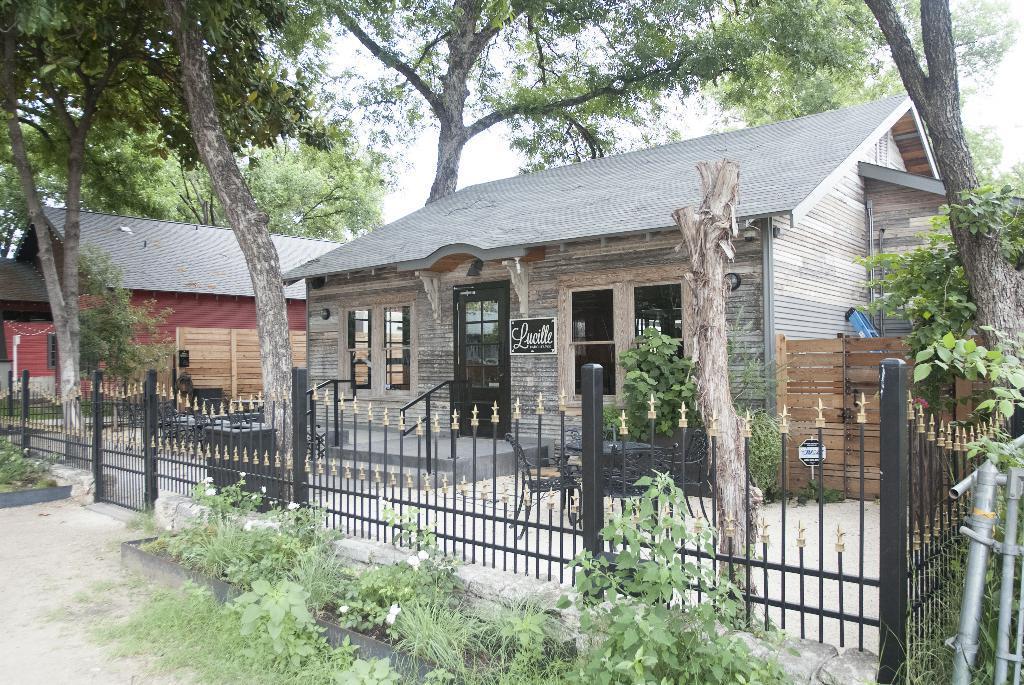Can you describe this image briefly? In this image in the front there are plants. In the center there is fence. In the background there are houses and trees and the sky is cloudy. On the right side there are objects which are silver in colour. 